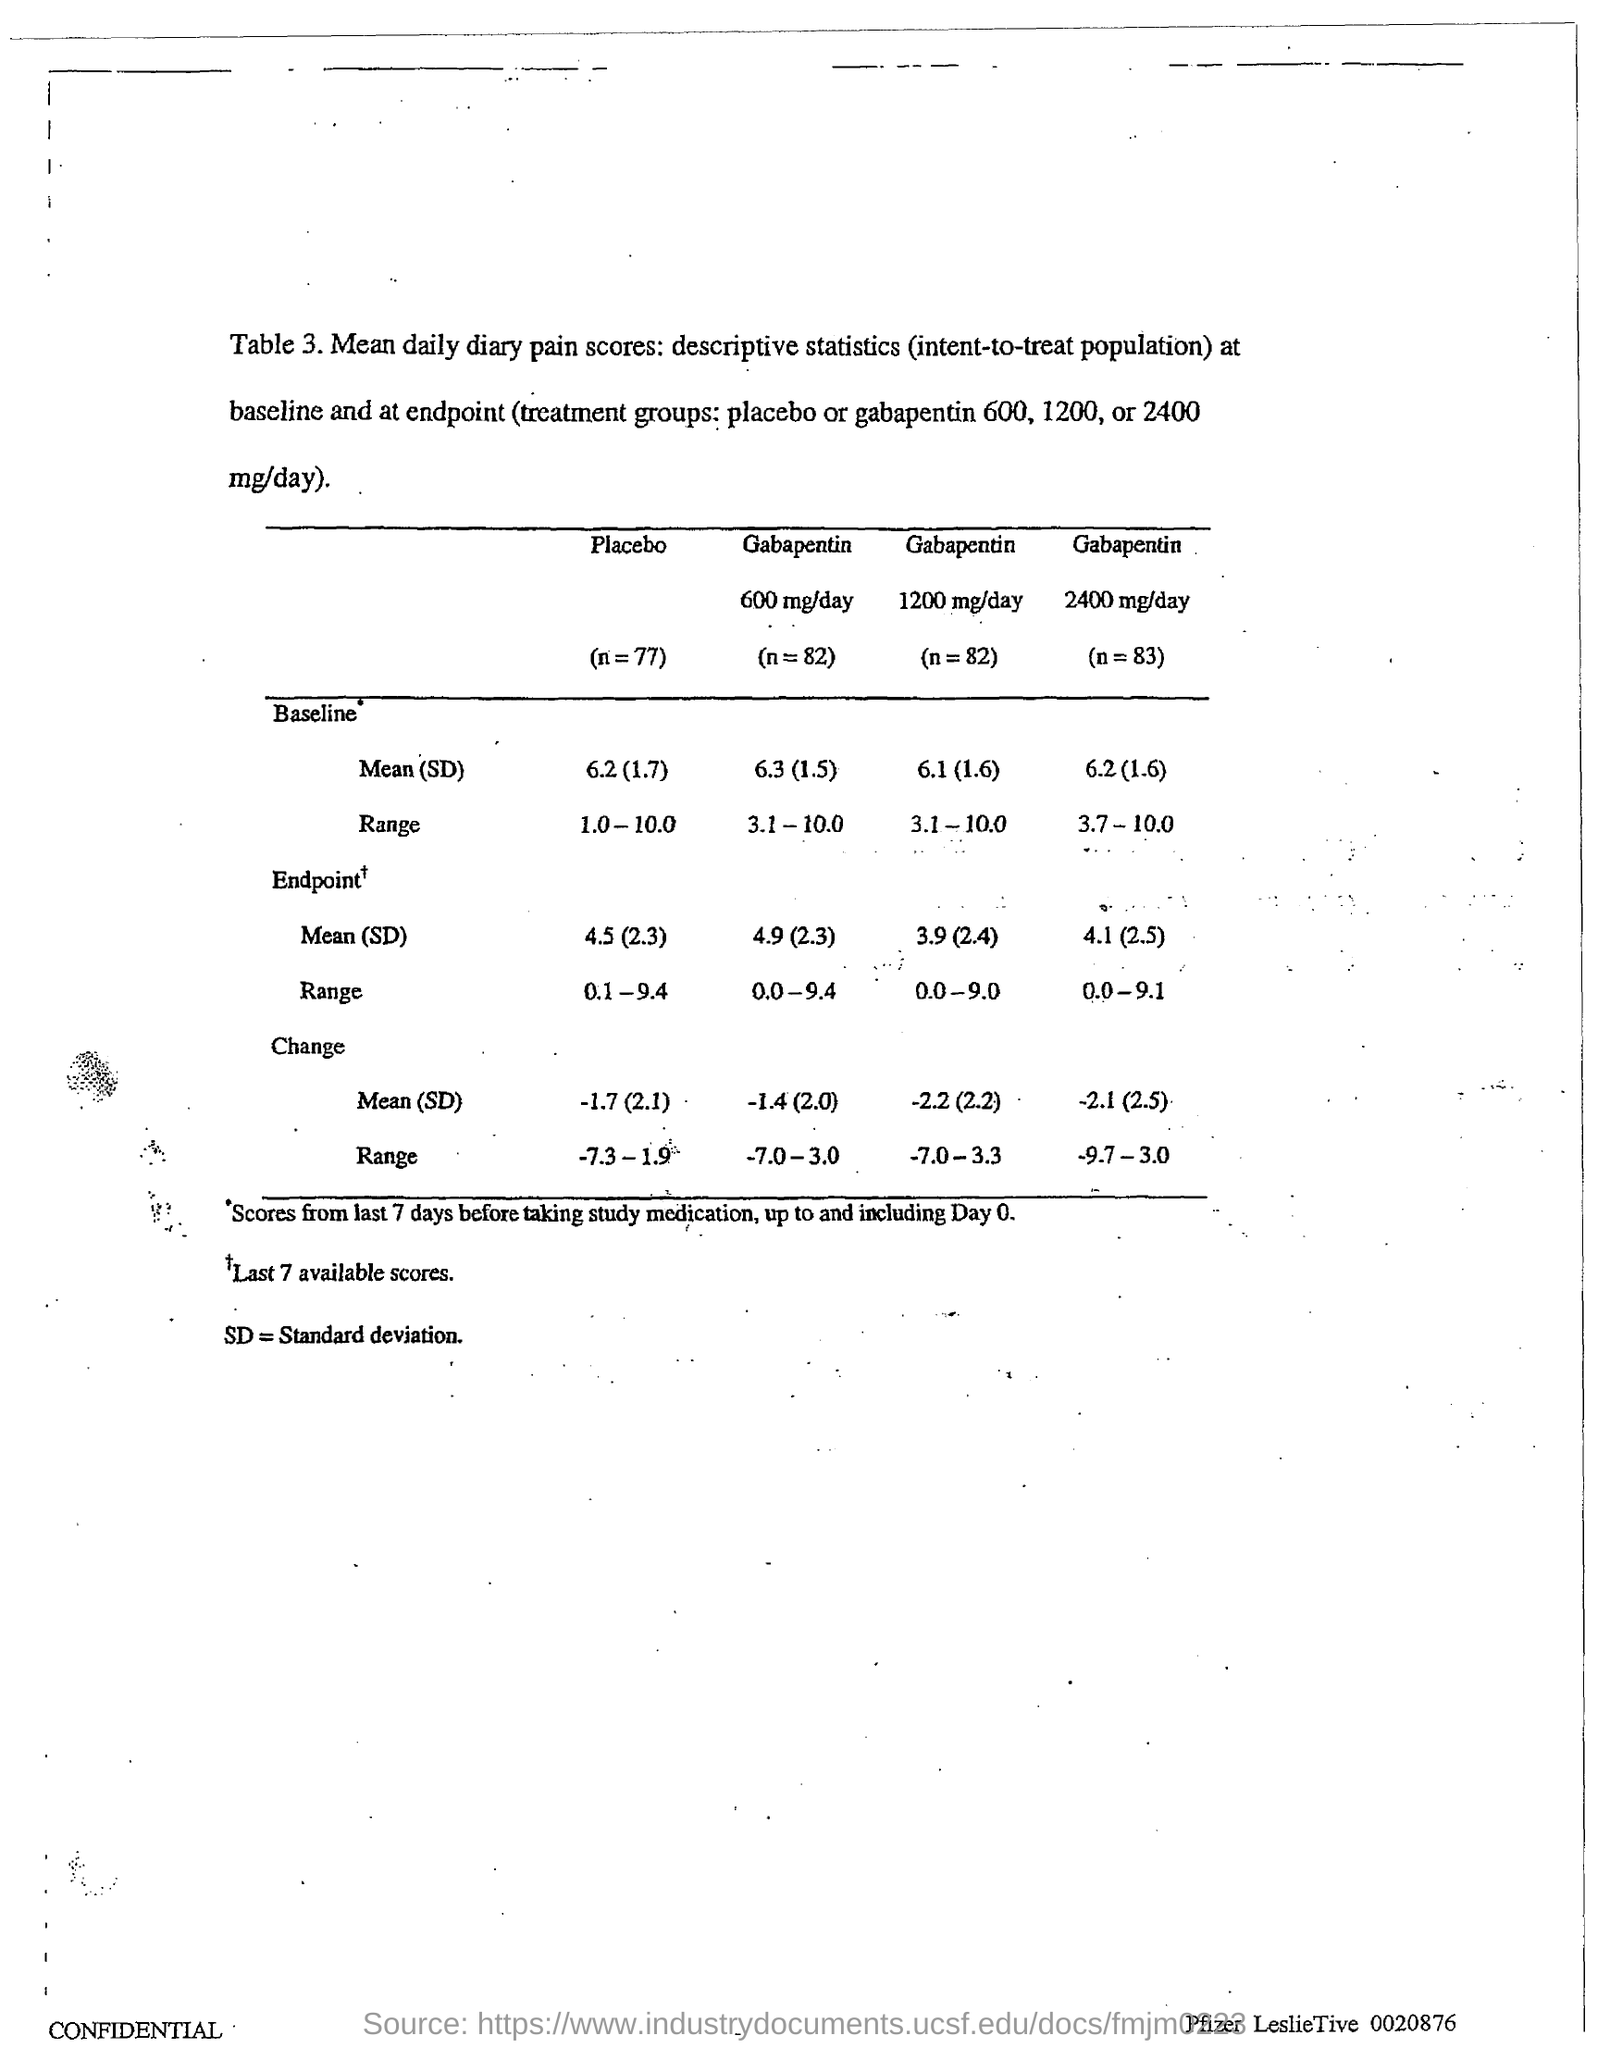Outline some significant characteristics in this image. The term 'Standard Deviation' refers to a statistical measure that represents the amount of variation or dispersion in a dataset. 